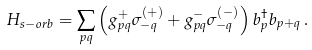<formula> <loc_0><loc_0><loc_500><loc_500>H _ { s - o r b } = \sum _ { p q } \left ( g ^ { + } _ { p q } \sigma ^ { ( + ) } _ { - q } + g ^ { - } _ { p q } \sigma ^ { ( - ) } _ { - q } \right ) b ^ { \dagger } _ { p } b _ { p + q } \, .</formula> 